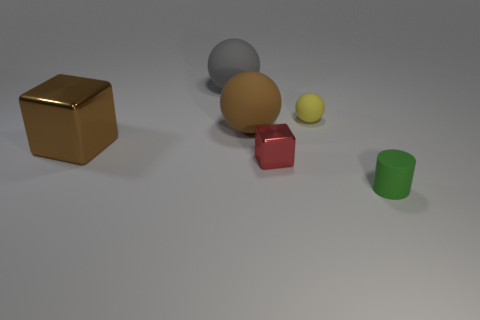Are there any other things that have the same color as the tiny cylinder?
Offer a terse response. No. There is a big brown thing that is the same shape as the red thing; what is its material?
Offer a terse response. Metal. How many other things are there of the same shape as the big brown rubber thing?
Provide a succinct answer. 2. What number of things are small yellow objects or rubber objects that are to the right of the large gray matte thing?
Make the answer very short. 3. Is there a red metallic thing of the same size as the yellow rubber ball?
Your response must be concise. Yes. Does the large gray ball have the same material as the small yellow object?
Your answer should be very brief. Yes. What number of things are balls or big purple balls?
Keep it short and to the point. 3. How big is the brown ball?
Offer a terse response. Large. Is the number of small yellow rubber things less than the number of blue matte spheres?
Make the answer very short. No. How many big things are the same color as the matte cylinder?
Your response must be concise. 0. 